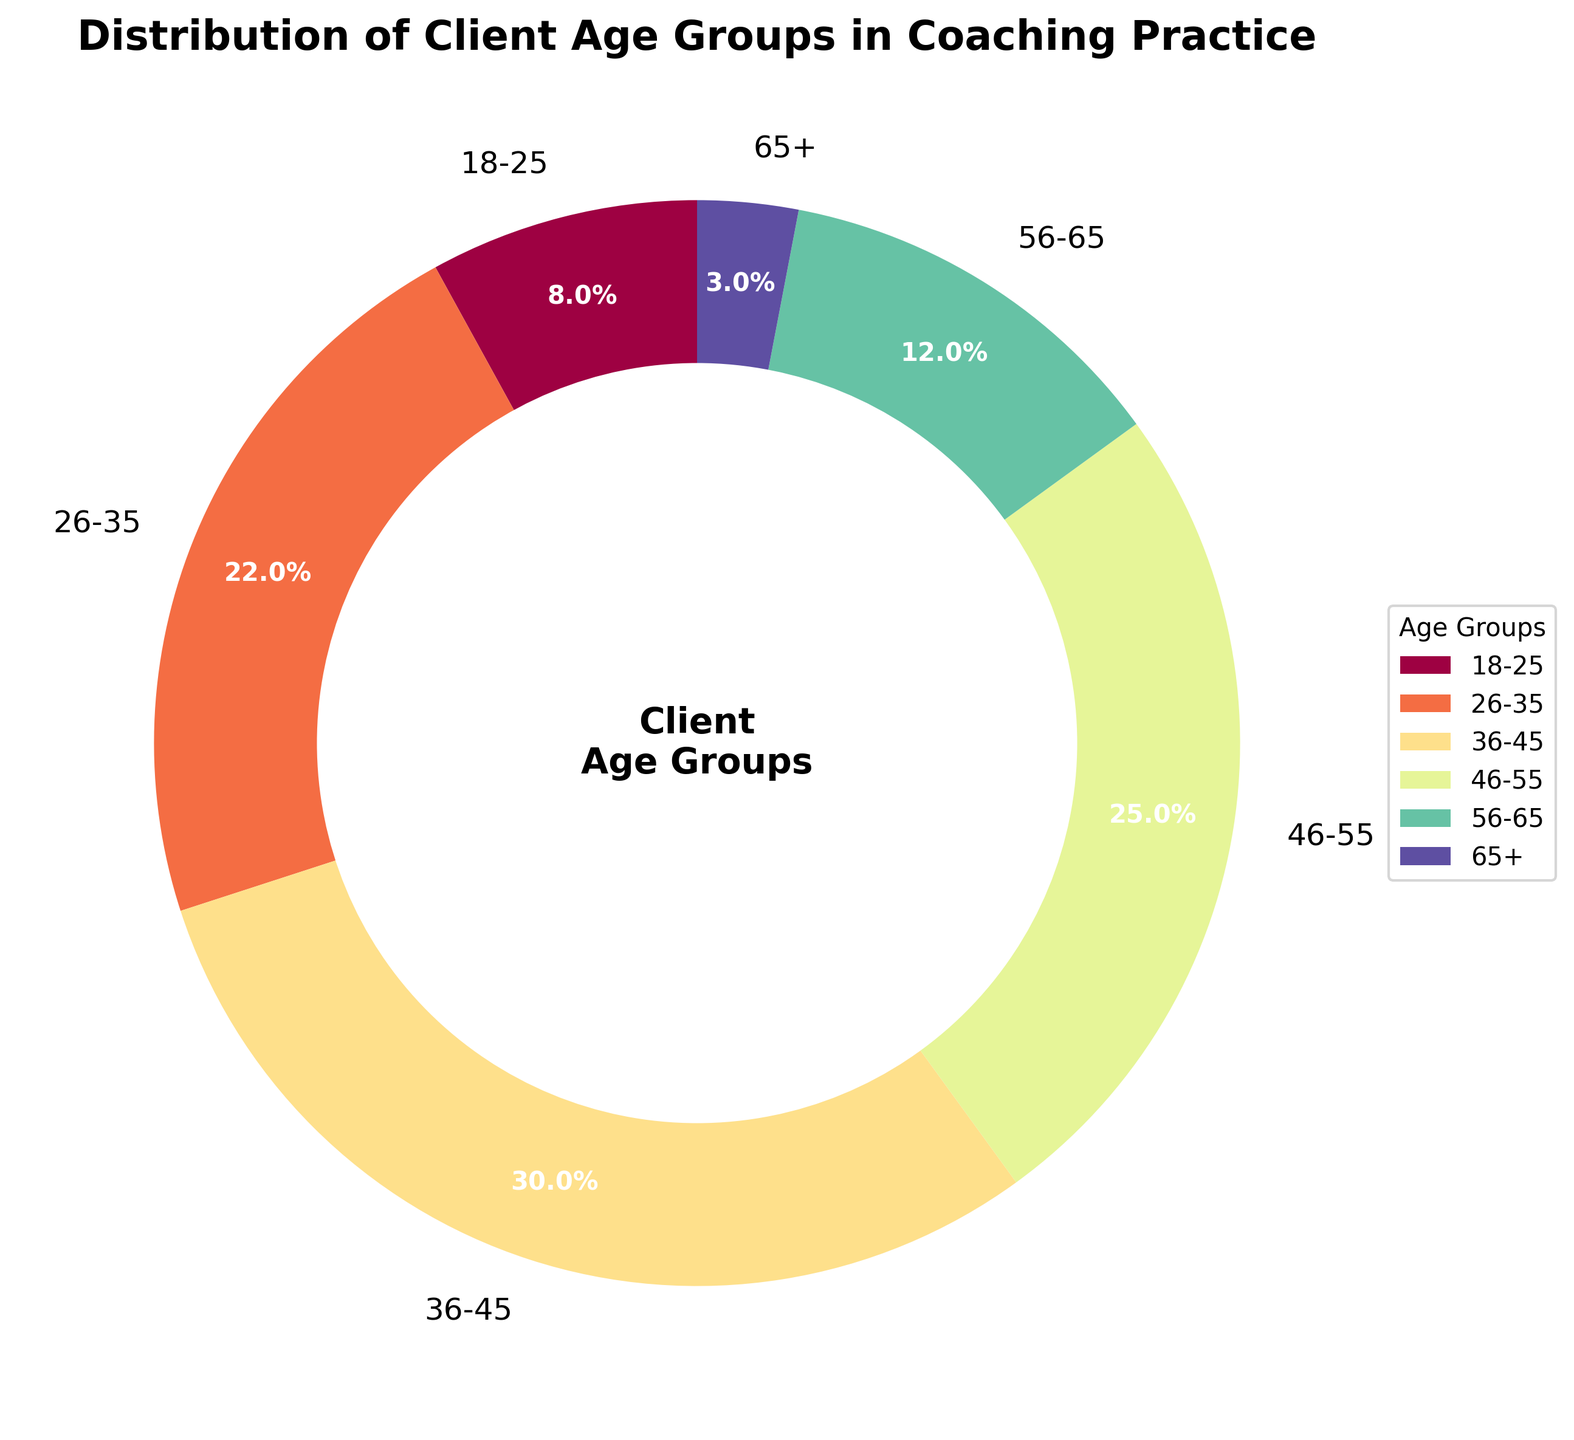What is the most represented age group in the coaching practice? The age group with the highest percentage in the pie chart represents the most represented age group. By looking at the chart, the 36-45 age group has the largest wedge.
Answer: 36-45 Which age group has the smallest representation? The age group with the smallest percentage in the pie chart represents the least represented age group. The wedge for the 65+ age group is the smallest.
Answer: 65+ What is the combined percentage of clients aged 36-55? Sum the percentages of the 36-45 age group and the 46-55 age group: 30% + 25% = 55%.
Answer: 55% How much larger is the 36-45 age group compared to the 65+ age group? Subtract the percentage of the 65+ age group from the percentage of the 36-45 age group: 30% - 3% = 27%.
Answer: 27% What is the percentage difference between the two largest age groups? Identify the two largest age groups, which are 36-45 (30%) and 46-55 (25%). Subtract the second largest from the largest: 30% - 25% = 5%.
Answer: 5% If we combine the clients under 35, what percentage do they represent? Add the percentages of the 18-25 and 26-35 age groups: 8% + 22% = 30%.
Answer: 30% Which age group percentage is closest to the average of all age groups? First, calculate the average percentage of all age groups: (8% + 22% + 30% + 25% + 12% + 3%) / 6 ≈ 16.67%. Then, compare this to each age group and see which one is closest: The 18-25 age group at 8%, 26-35 at 22%, 36-45 at 30%, 46-55 at 25%, 56-65 at 12%, and 65+ at 3%. The 18-25 age group, at 8%, is closest.
Answer: 18-25 Looking at the visual attributes, which color represents the 56-65 age group? Identify the section of the pie chart labeled "56-65" and observe its color. According to the gradient used, it appears to be a shade between the colors used for the 46-55 and 65+ groups.
Answer: Light orange (or specify the precise color based on the visual cues given) How much more represented is the age group 26-35 compared to the age group 18-25? Subtract the percentage of the 18-25 age group from the percentage of the 26-35 age group: 22% - 8% = 14%.
Answer: 14% Which two age groups combined make up less than the percentage of the 36-45 age group? Determine the pair of age groups whose combined percentage is less than 30%. The pairs (18-25 and 65+) add up to 11%, which is less than 30%.
Answer: 18-25 and 65+ 